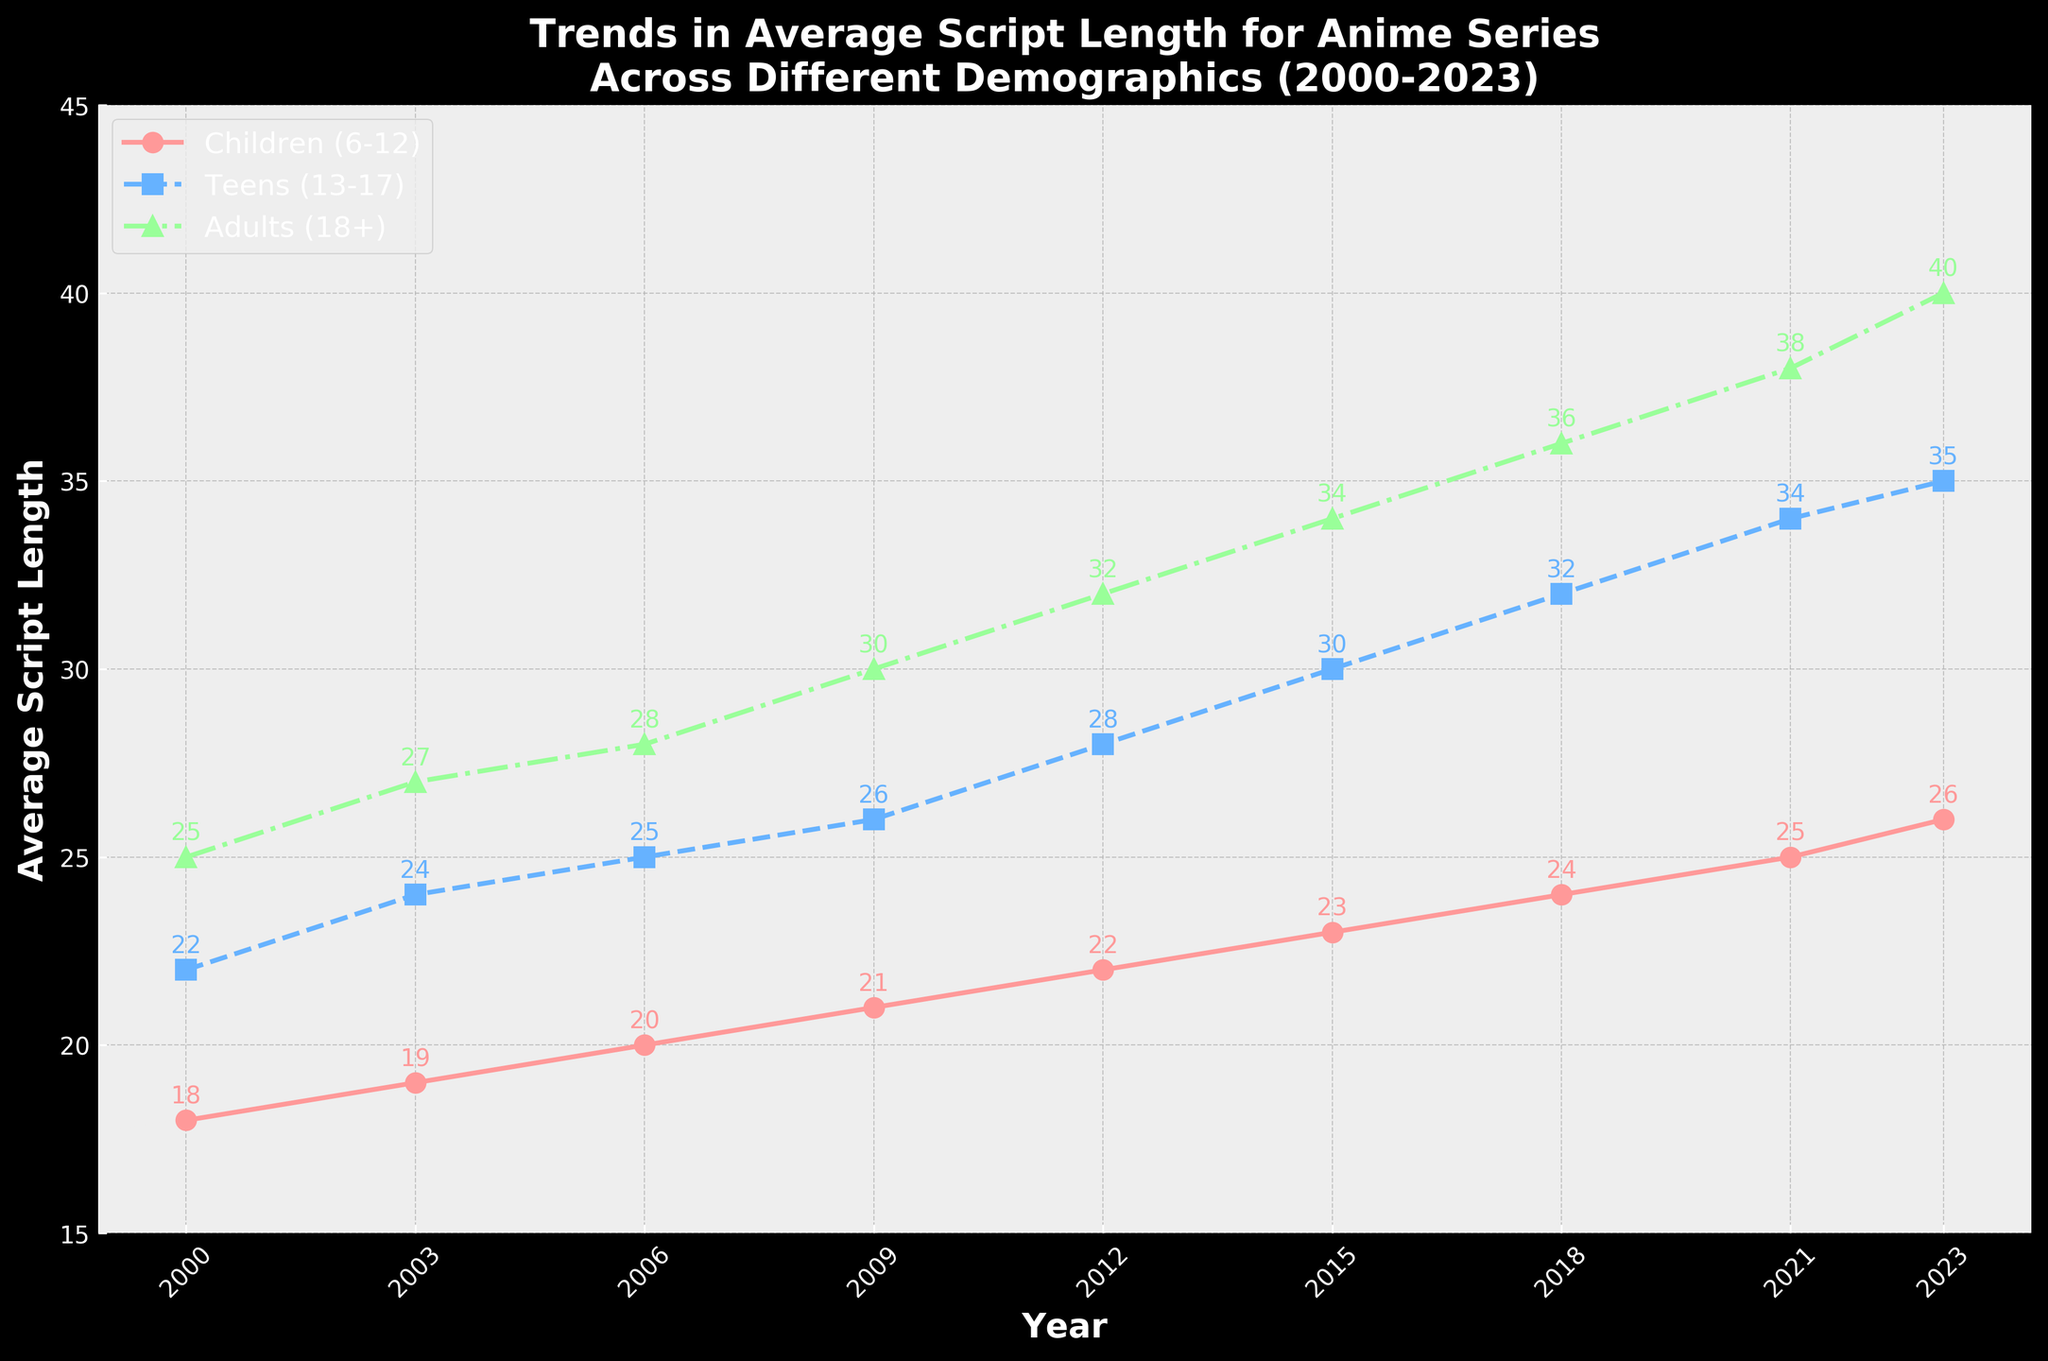What's the average script length for anime series targeted at children in the years 2000 and 2023? To find the average, sum the script lengths for 2000 and 2023 and then divide by 2. The values are 18 (for 2000) and 26 (for 2023). So, (18 + 26) / 2 = 22.
Answer: 22 Which demographic had the highest average script length in 2023? In the year 2023, compare the average script lengths for children (26), teens (35), and adults (40). The adults demographic has the highest average script length at 40.
Answer: Adults Between 2009 and 2021, which demographic showed the greatest increase in average script length? Calculate the difference between the script lengths of 2009 and 2021 for each demographic. Children: 25 - 21 = 4; Teens: 34 - 26 = 8; Adults: 38 - 30 = 8. The records show that both teens and adults had the greatest increase of 8.
Answer: Teens and Adults Which line on the graph represents anime series targeted at teens? Look for the line with markers and colors used in the plot for teens. The teens' line is marked with squares and is blue with a dashed line.
Answer: Blue dashed line with square markers What was the script length for adults in 2015, and how does it compare to teens in the same year? The script length for adults in 2015 was 34, while for teens, it was 30. To compare, 34 is greater than 30, so the adult script length was higher than the teens' script length in 2015.
Answer: Adults had higher script length 